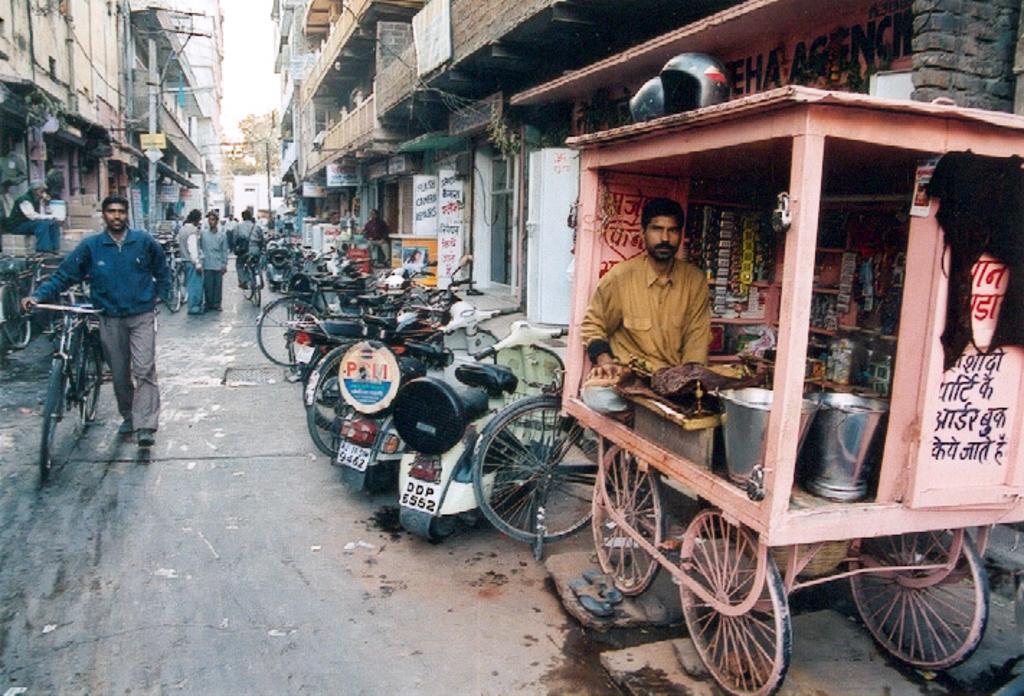Can you describe this image briefly? On the right side of the image we can see a trolley cart in which there are bucket, a man sitting inside it and a mini shop. There is a helmet on the top of it. There are many vehicles parked on the road. In the background of the image we can see many buildings. 